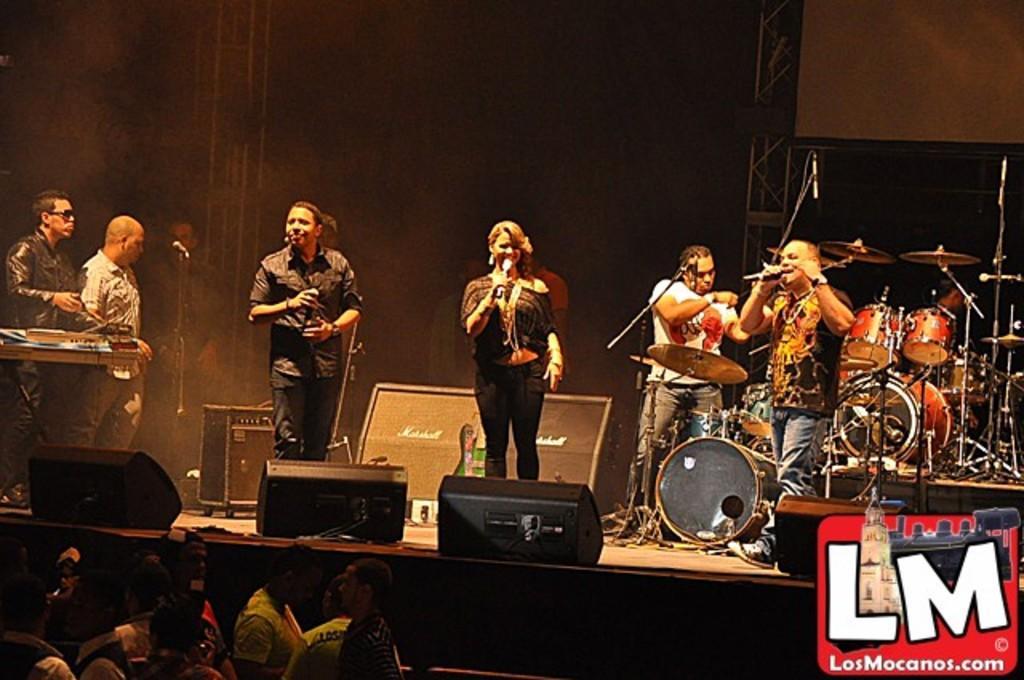How would you summarize this image in a sentence or two? At the bottom of the picture, we see the people are standing. In the middle of the picture, we see the woman and five men are standing. Three of them are holding the microphones. The man on the right side is singing the song on the microphone. Behind him, we see a man is playing the drums. On the left side, we see two men are standing. In front of them, we see a table. Behind them, we see the speaker boxes. In the background, it is black in color. This picture is clicked in the musical concert. 